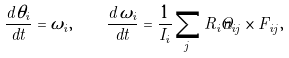Convert formula to latex. <formula><loc_0><loc_0><loc_500><loc_500>\frac { d \theta _ { i } } { d t } = \omega _ { i } , \quad \frac { d \omega _ { i } } { d t } = \frac { 1 } { I _ { i } } \sum _ { j } R _ { i } \hat { n } _ { i j } \times F _ { i j } ,</formula> 